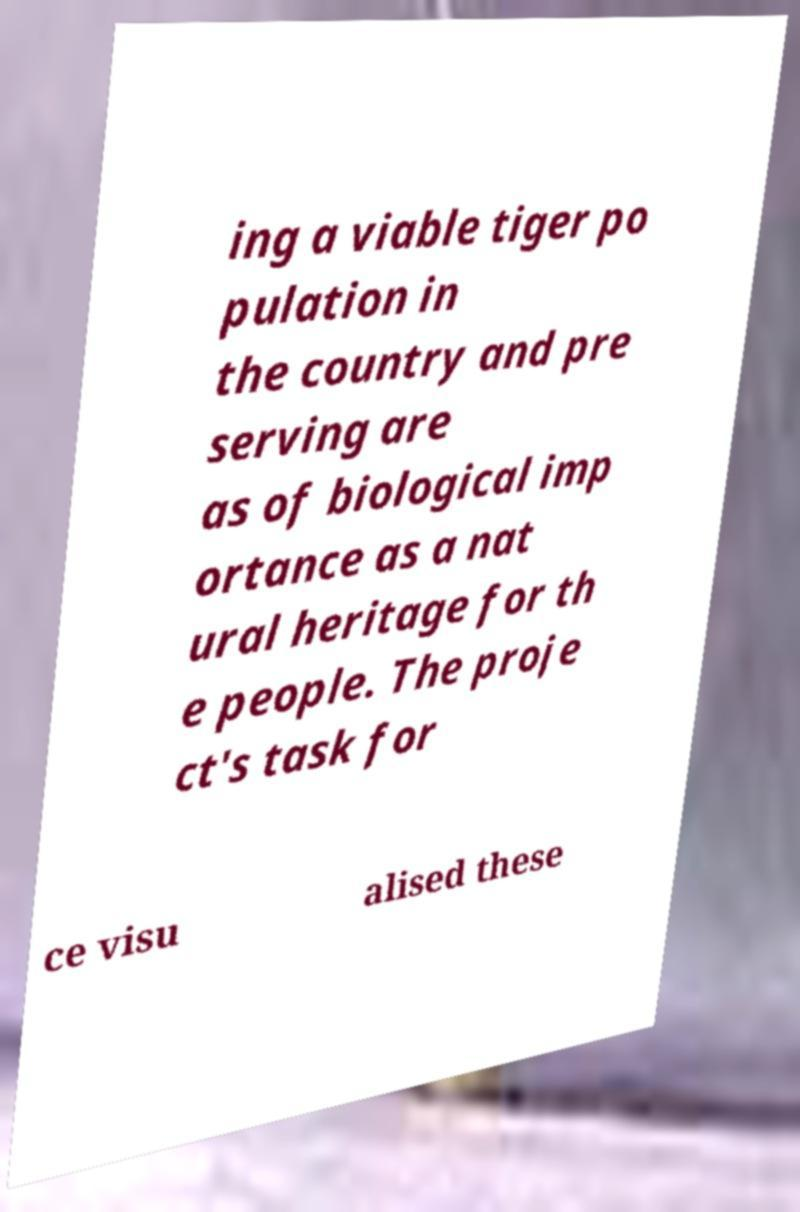Please read and relay the text visible in this image. What does it say? ing a viable tiger po pulation in the country and pre serving are as of biological imp ortance as a nat ural heritage for th e people. The proje ct's task for ce visu alised these 